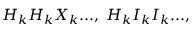Convert formula to latex. <formula><loc_0><loc_0><loc_500><loc_500>H _ { k } H _ { k } X _ { k } \dots , \, H _ { k } I _ { k } I _ { k } \dots ,</formula> 